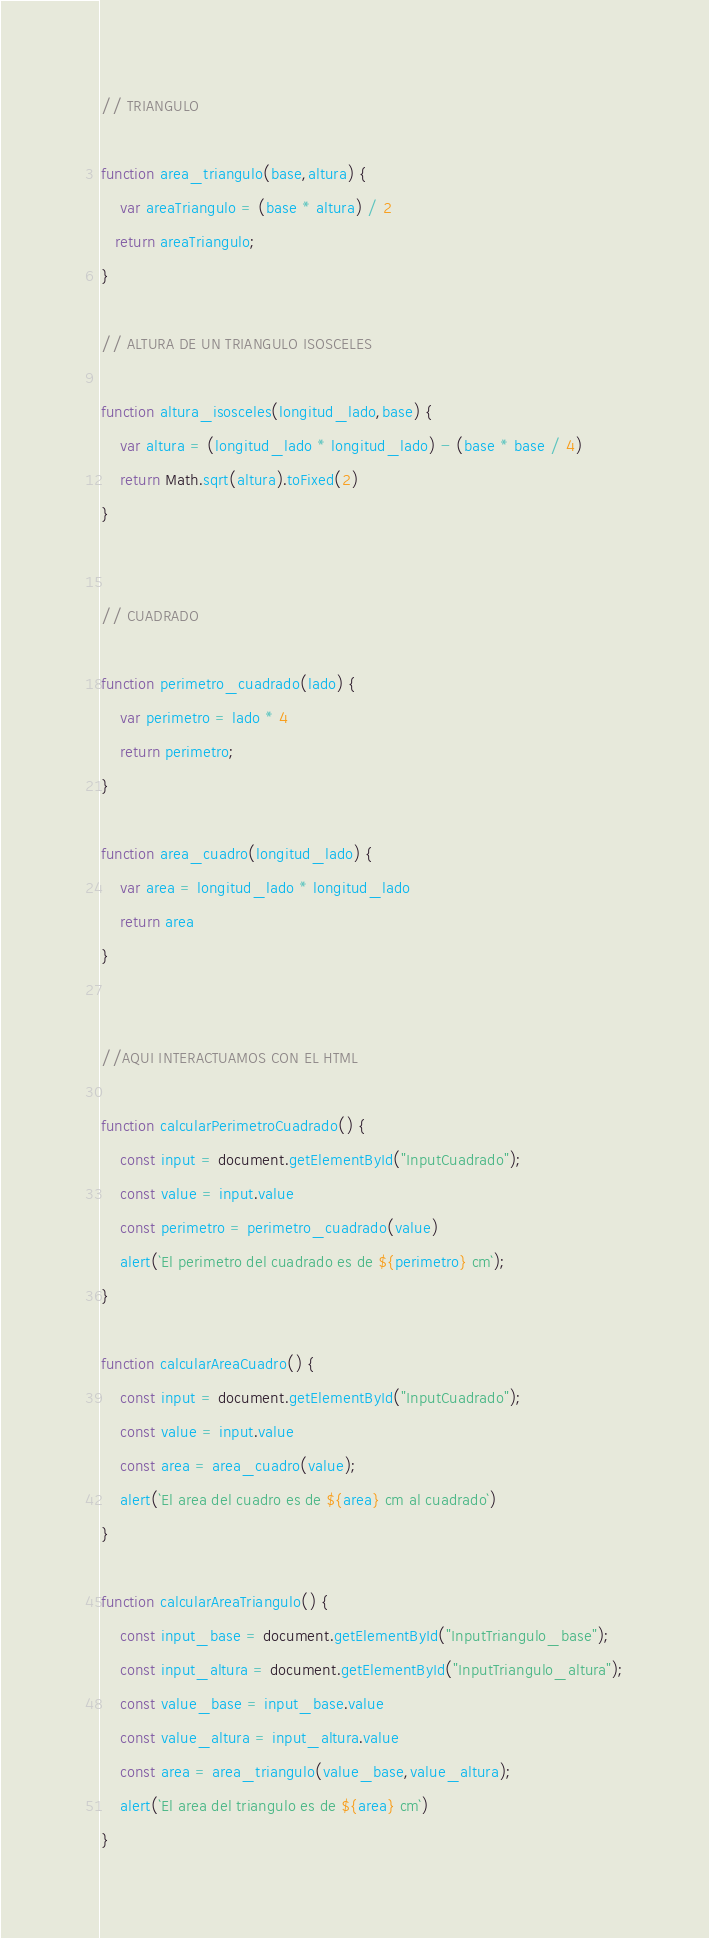<code> <loc_0><loc_0><loc_500><loc_500><_JavaScript_>// TRIANGULO

function area_triangulo(base,altura) {
    var areaTriangulo = (base * altura) / 2
   return areaTriangulo;
}

// ALTURA DE UN TRIANGULO ISOSCELES 

function altura_isosceles(longitud_lado,base) {
    var altura = (longitud_lado * longitud_lado) - (base * base / 4)
    return Math.sqrt(altura).toFixed(2)
}


// CUADRADO

function perimetro_cuadrado(lado) {
    var perimetro = lado * 4
    return perimetro;
}

function area_cuadro(longitud_lado) {
    var area = longitud_lado * longitud_lado
    return area
}


//AQUI INTERACTUAMOS CON EL HTML

function calcularPerimetroCuadrado() {
    const input = document.getElementById("InputCuadrado");
    const value = input.value
    const perimetro = perimetro_cuadrado(value)
    alert(`El perimetro del cuadrado es de ${perimetro} cm`);
}

function calcularAreaCuadro() {
    const input = document.getElementById("InputCuadrado");
    const value = input.value
    const area = area_cuadro(value);
    alert(`El area del cuadro es de ${area} cm al cuadrado`)
}

function calcularAreaTriangulo() {
    const input_base = document.getElementById("InputTriangulo_base");
    const input_altura = document.getElementById("InputTriangulo_altura");
    const value_base = input_base.value
    const value_altura = input_altura.value
    const area = area_triangulo(value_base,value_altura);
    alert(`El area del triangulo es de ${area} cm`)  
}</code> 